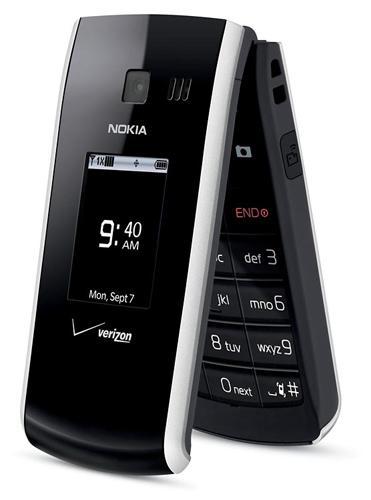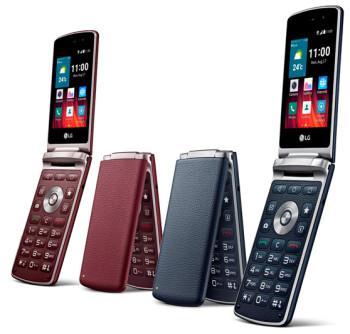The first image is the image on the left, the second image is the image on the right. Given the left and right images, does the statement "At least one image shows the side profile of a phone." hold true? Answer yes or no. No. The first image is the image on the left, the second image is the image on the right. For the images shown, is this caption "There is a total of six flip phones." true? Answer yes or no. No. 